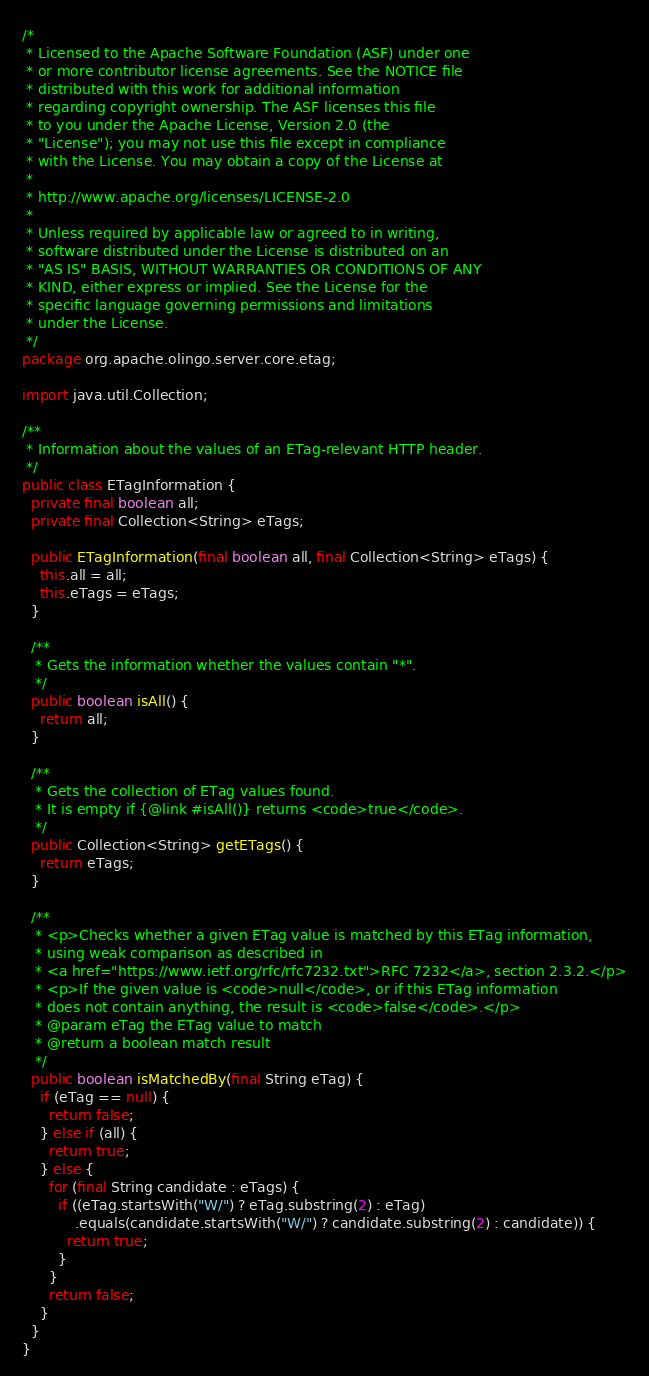Convert code to text. <code><loc_0><loc_0><loc_500><loc_500><_Java_>/*
 * Licensed to the Apache Software Foundation (ASF) under one
 * or more contributor license agreements. See the NOTICE file
 * distributed with this work for additional information
 * regarding copyright ownership. The ASF licenses this file
 * to you under the Apache License, Version 2.0 (the
 * "License"); you may not use this file except in compliance
 * with the License. You may obtain a copy of the License at
 *
 * http://www.apache.org/licenses/LICENSE-2.0
 *
 * Unless required by applicable law or agreed to in writing,
 * software distributed under the License is distributed on an
 * "AS IS" BASIS, WITHOUT WARRANTIES OR CONDITIONS OF ANY
 * KIND, either express or implied. See the License for the
 * specific language governing permissions and limitations
 * under the License.
 */
package org.apache.olingo.server.core.etag;

import java.util.Collection;

/**
 * Information about the values of an ETag-relevant HTTP header.
 */
public class ETagInformation {
  private final boolean all;
  private final Collection<String> eTags;

  public ETagInformation(final boolean all, final Collection<String> eTags) {
    this.all = all;
    this.eTags = eTags;
  }

  /**
   * Gets the information whether the values contain "*".
   */
  public boolean isAll() {
    return all;
  }

  /**
   * Gets the collection of ETag values found.
   * It is empty if {@link #isAll()} returns <code>true</code>.
   */
  public Collection<String> getETags() {
    return eTags;
  }

  /**
   * <p>Checks whether a given ETag value is matched by this ETag information,
   * using weak comparison as described in
   * <a href="https://www.ietf.org/rfc/rfc7232.txt">RFC 7232</a>, section 2.3.2.</p>
   * <p>If the given value is <code>null</code>, or if this ETag information
   * does not contain anything, the result is <code>false</code>.</p>
   * @param eTag the ETag value to match
   * @return a boolean match result
   */
  public boolean isMatchedBy(final String eTag) {
    if (eTag == null) {
      return false;
    } else if (all) {
      return true;
    } else {
      for (final String candidate : eTags) {
        if ((eTag.startsWith("W/") ? eTag.substring(2) : eTag)
            .equals(candidate.startsWith("W/") ? candidate.substring(2) : candidate)) {
          return true;
        }
      }
      return false;
    }
  }
}</code> 